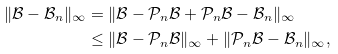<formula> <loc_0><loc_0><loc_500><loc_500>\| \mathcal { B } - \mathcal { B } _ { n } \| _ { \infty } & = \| \mathcal { B } - \mathcal { P } _ { n } \mathcal { B } + \mathcal { P } _ { n } \mathcal { B } - \mathcal { B } _ { n } \| _ { \infty } \\ & \leq \| \mathcal { B } - \mathcal { P } _ { n } \mathcal { B } \| _ { \infty } + \| \mathcal { P } _ { n } \mathcal { B } - \mathcal { B } _ { n } \| _ { \infty } ,</formula> 